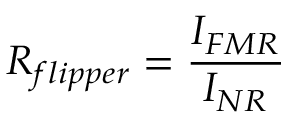Convert formula to latex. <formula><loc_0><loc_0><loc_500><loc_500>R _ { f l i p p e r } = \frac { I _ { F M R } } { I _ { N R } }</formula> 